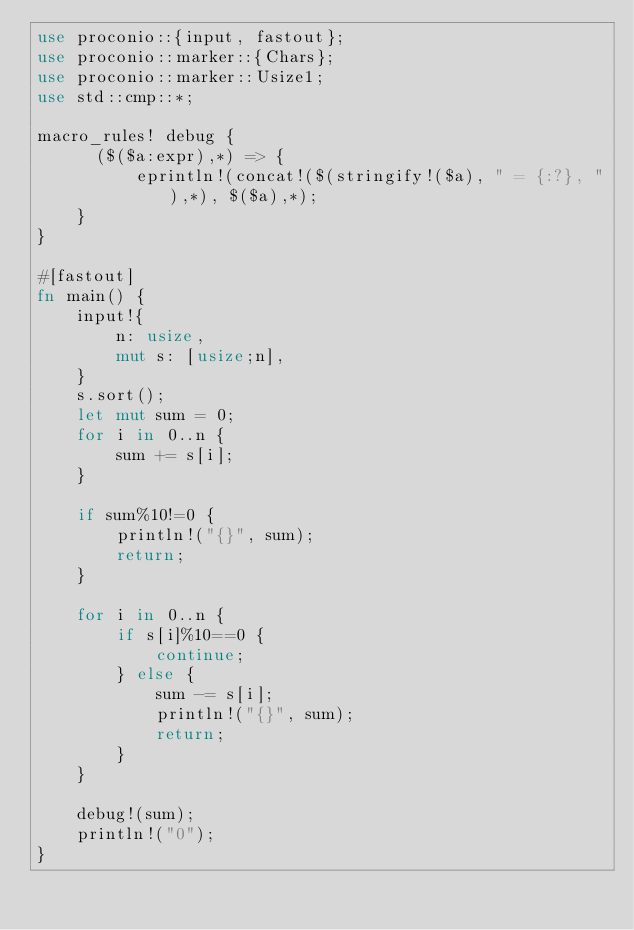<code> <loc_0><loc_0><loc_500><loc_500><_Rust_>use proconio::{input, fastout};
use proconio::marker::{Chars};
use proconio::marker::Usize1;
use std::cmp::*;

macro_rules! debug {
      ($($a:expr),*) => {
          eprintln!(concat!($(stringify!($a), " = {:?}, "),*), $($a),*);
    }
}

#[fastout]
fn main() {
    input!{
        n: usize,
        mut s: [usize;n],
    }
    s.sort();
    let mut sum = 0;
    for i in 0..n {
        sum += s[i];
    }
    
    if sum%10!=0 {
        println!("{}", sum);
        return;
    }
    
    for i in 0..n {
        if s[i]%10==0 {
            continue;
        } else {
            sum -= s[i];
            println!("{}", sum);
            return;
        }
    }

    debug!(sum);
    println!("0");
}
</code> 